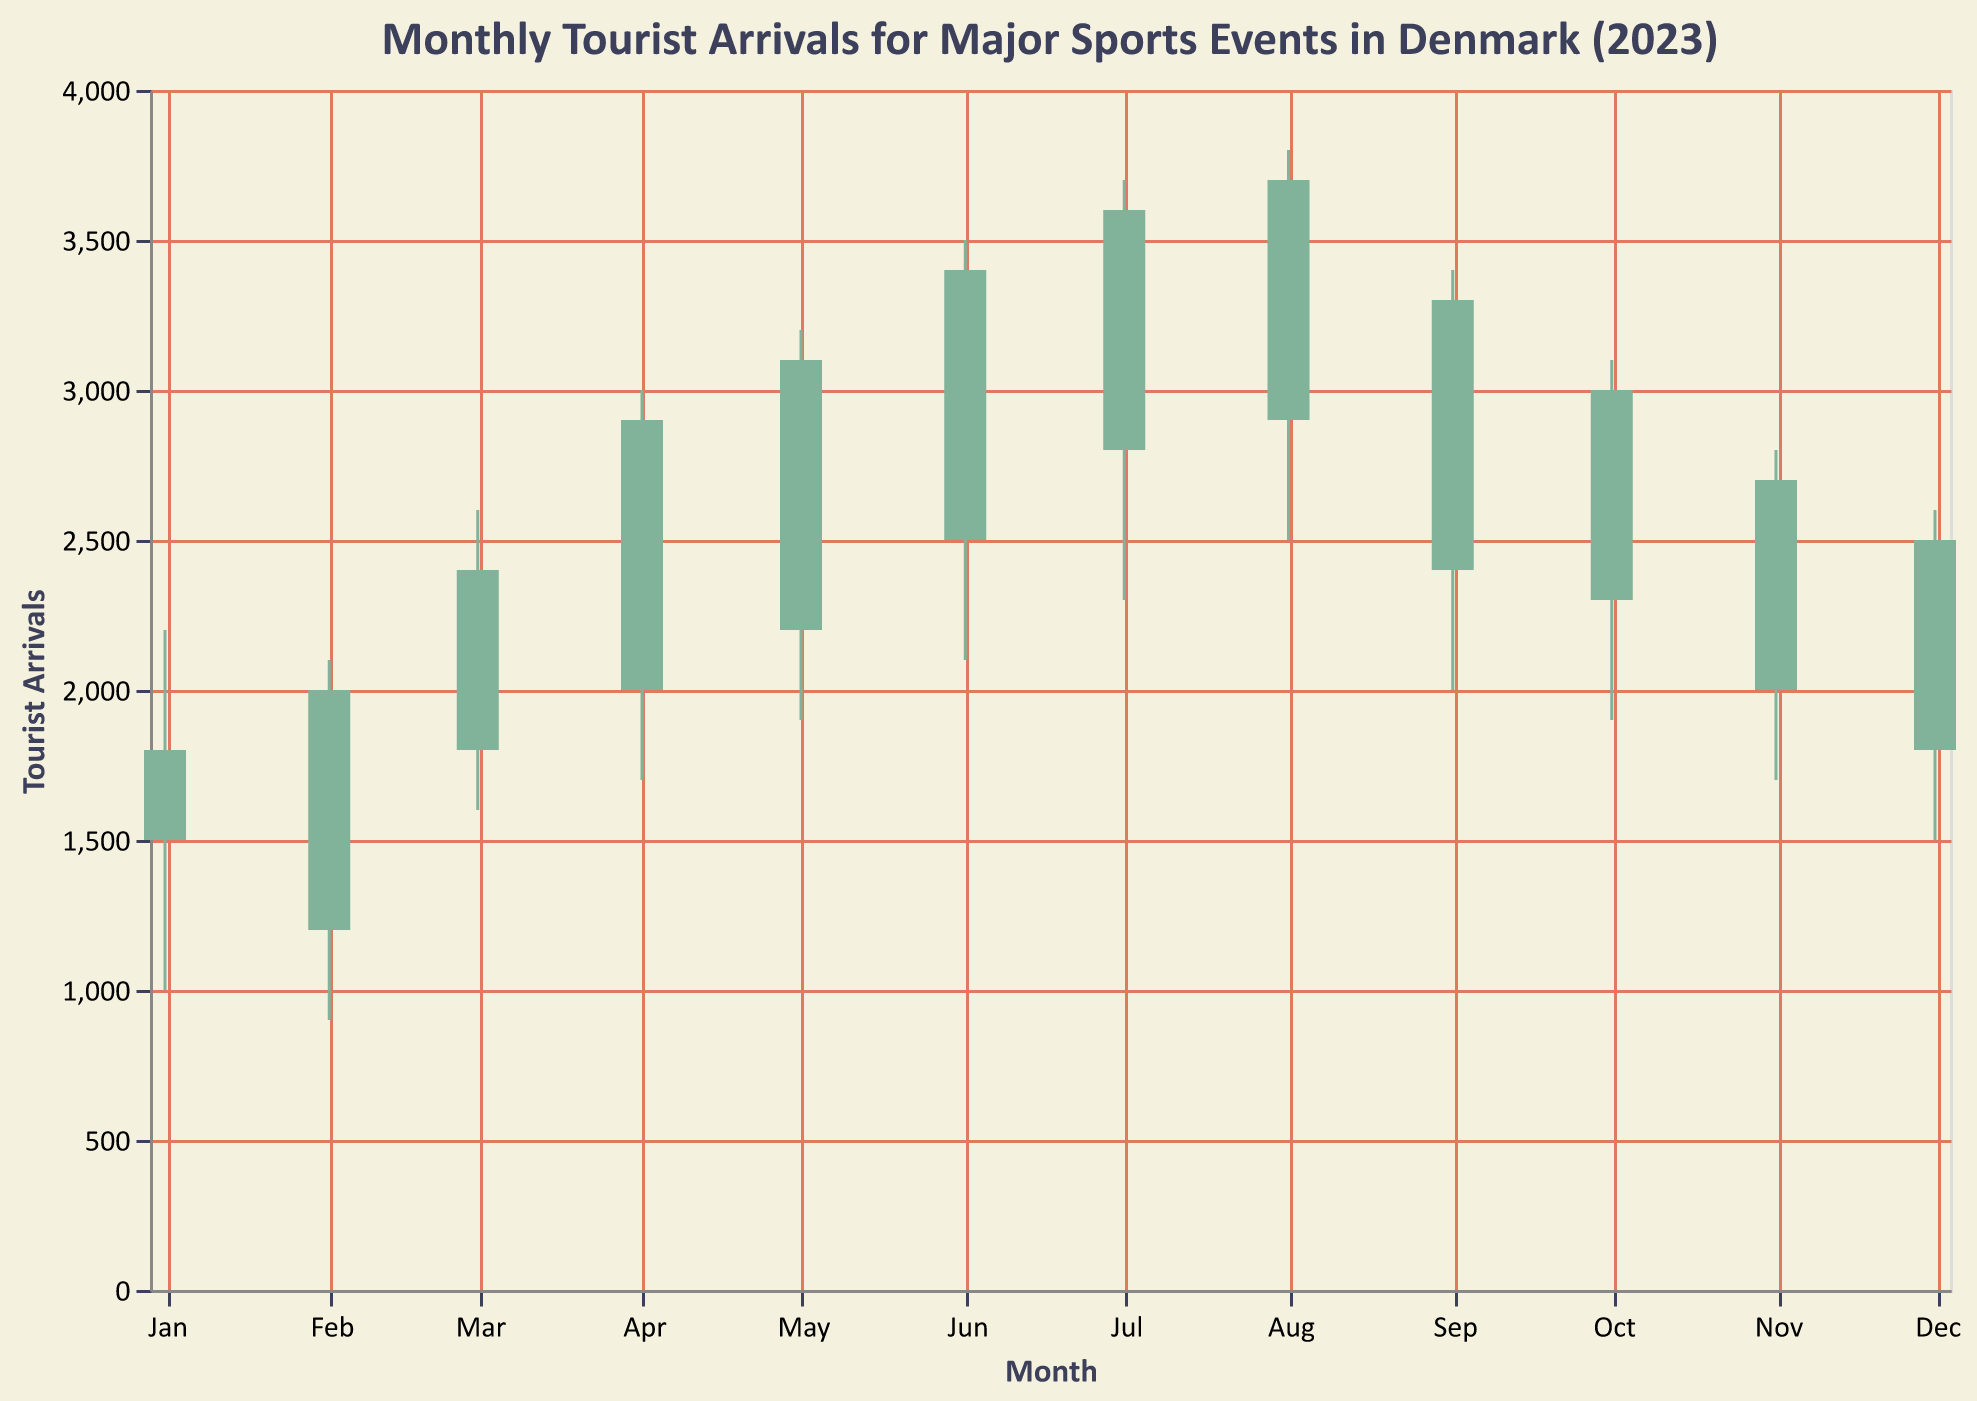What is the event with the highest tourist arrivals at its peak? Look for the candlestick with the highest "High" value. The "Copenhagen Ironman" in August has the highest peak value at 3800.
Answer: Copenhagen Ironman Which month had the lowest number of tourist arrivals for any event? Look for the candlestick with the lowest "Low" value. The "Aarhus Winter Games" in February had the lowest low value of 900.
Answer: February Which events closed with a higher value than they opened? Identify the candlesticks that are colored differently (green) indicating that the "Close" value is higher than the "Open" value. These events are "Aarhus Winter Games" (February), "Odense Spring Half Marathon" (March), "Copenhagen Bike Week" (April), "Esbjerg Beach Volleyball Tournament" (May), "Roskilde Festival Sports Events" (June), "Aalborg Triathlon Championship" (July), "Copenhagen Ironman" (August), and "Vejle Cycling Tour" (September).
Answer: Aarhus Winter Games, Odense Spring Half Marathon, Copenhagen Bike Week, Esbjerg Beach Volleyball Tournament, Roskilde Festival Sports Events, Aalborg Triathlon Championship, Copenhagen Ironman, Vejle Cycling Tour What were the tourist arrival values of the event at Vejle in September? Refer to the data points for "Vejle Cycling Tour" in September. The values are: Open = 2400, High = 3400, Low = 2000, Close = 3300.
Answer: Open: 2400, High: 3400, Low: 2000, Close: 3300 Which month shows the widest range of tourist arrivals? Calculate the range (High - Low) for each month and compare. "Copenhagen Ironman" in August shows the widest range with a high of 3800 and a low of 2500, resulting in a range of 1300.
Answer: August Which event had the smallest difference between open and close tourist arrivals? Calculate the absolute difference between "Open" and "Close" values for each event and compare. "Horsens Indoor Sports Festival" in November had the smallest difference of 2000 - 2700 = 700.
Answer: Horsens Indoor Sports Festival By how much did the "New Year Marathon" tourist arrivals increase from opening to closing? Subtract the "Open" value from the "Close" value for "New Year Marathon" in January. The increase is 1800 - 1500 = 300.
Answer: 300 Which two consecutive months showed a consistent increase in tourist arrivals? Identify months where the "Close" value of one month is less than the "Open" value of the following month. June (Roskilde Festival Sports Events) to July (Aalborg Triathlon Championship) shows this pattern.
Answer: June to July What is the total highest tourist arrival sum for the events in the summer months (June, July, August)? Sum the "High" values for June, July, and August. The sum is 3500 (June) + 3700 (July) + 3800 (August) = 11000.
Answer: 11000 Which event had the highest tourist arrival value in December and what was that value? Look for the candlestick in December for "Silkeborg Christmas Ski Event" and find the "High" value. The highest tourist arrival value was 2600.
Answer: Silkeborg Christmas Ski Event, 2600 